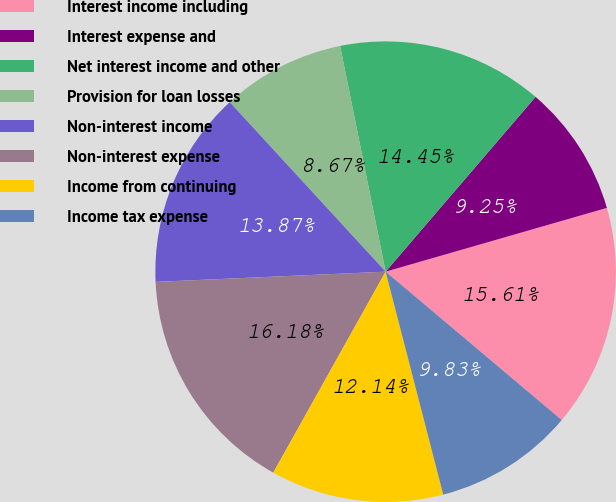<chart> <loc_0><loc_0><loc_500><loc_500><pie_chart><fcel>Interest income including<fcel>Interest expense and<fcel>Net interest income and other<fcel>Provision for loan losses<fcel>Non-interest income<fcel>Non-interest expense<fcel>Income from continuing<fcel>Income tax expense<nl><fcel>15.61%<fcel>9.25%<fcel>14.45%<fcel>8.67%<fcel>13.87%<fcel>16.18%<fcel>12.14%<fcel>9.83%<nl></chart> 